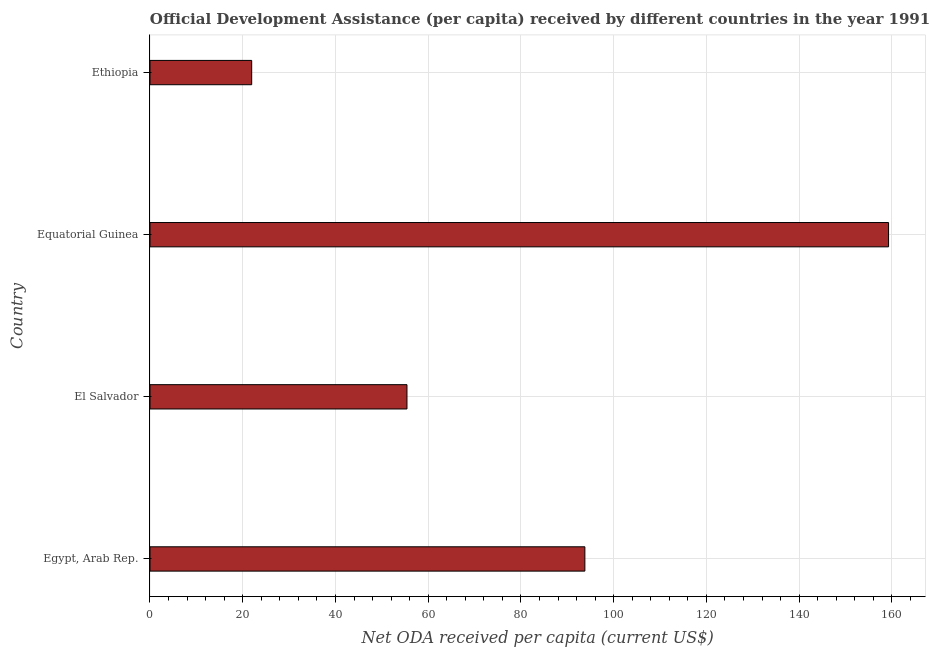Does the graph contain grids?
Your response must be concise. Yes. What is the title of the graph?
Offer a very short reply. Official Development Assistance (per capita) received by different countries in the year 1991. What is the label or title of the X-axis?
Your answer should be compact. Net ODA received per capita (current US$). What is the label or title of the Y-axis?
Offer a terse response. Country. What is the net oda received per capita in Equatorial Guinea?
Ensure brevity in your answer.  159.28. Across all countries, what is the maximum net oda received per capita?
Your answer should be very brief. 159.28. Across all countries, what is the minimum net oda received per capita?
Keep it short and to the point. 21.93. In which country was the net oda received per capita maximum?
Ensure brevity in your answer.  Equatorial Guinea. In which country was the net oda received per capita minimum?
Offer a terse response. Ethiopia. What is the sum of the net oda received per capita?
Ensure brevity in your answer.  330.42. What is the difference between the net oda received per capita in El Salvador and Ethiopia?
Offer a terse response. 33.49. What is the average net oda received per capita per country?
Give a very brief answer. 82.61. What is the median net oda received per capita?
Make the answer very short. 74.6. What is the ratio of the net oda received per capita in Egypt, Arab Rep. to that in Equatorial Guinea?
Your answer should be compact. 0.59. Is the net oda received per capita in El Salvador less than that in Equatorial Guinea?
Offer a very short reply. Yes. Is the difference between the net oda received per capita in El Salvador and Ethiopia greater than the difference between any two countries?
Ensure brevity in your answer.  No. What is the difference between the highest and the second highest net oda received per capita?
Offer a very short reply. 65.49. What is the difference between the highest and the lowest net oda received per capita?
Give a very brief answer. 137.35. Are all the bars in the graph horizontal?
Ensure brevity in your answer.  Yes. How many countries are there in the graph?
Your answer should be very brief. 4. Are the values on the major ticks of X-axis written in scientific E-notation?
Make the answer very short. No. What is the Net ODA received per capita (current US$) in Egypt, Arab Rep.?
Your answer should be very brief. 93.79. What is the Net ODA received per capita (current US$) of El Salvador?
Offer a very short reply. 55.42. What is the Net ODA received per capita (current US$) in Equatorial Guinea?
Keep it short and to the point. 159.28. What is the Net ODA received per capita (current US$) in Ethiopia?
Your response must be concise. 21.93. What is the difference between the Net ODA received per capita (current US$) in Egypt, Arab Rep. and El Salvador?
Make the answer very short. 38.37. What is the difference between the Net ODA received per capita (current US$) in Egypt, Arab Rep. and Equatorial Guinea?
Provide a short and direct response. -65.49. What is the difference between the Net ODA received per capita (current US$) in Egypt, Arab Rep. and Ethiopia?
Make the answer very short. 71.85. What is the difference between the Net ODA received per capita (current US$) in El Salvador and Equatorial Guinea?
Offer a very short reply. -103.86. What is the difference between the Net ODA received per capita (current US$) in El Salvador and Ethiopia?
Give a very brief answer. 33.49. What is the difference between the Net ODA received per capita (current US$) in Equatorial Guinea and Ethiopia?
Your answer should be very brief. 137.35. What is the ratio of the Net ODA received per capita (current US$) in Egypt, Arab Rep. to that in El Salvador?
Keep it short and to the point. 1.69. What is the ratio of the Net ODA received per capita (current US$) in Egypt, Arab Rep. to that in Equatorial Guinea?
Keep it short and to the point. 0.59. What is the ratio of the Net ODA received per capita (current US$) in Egypt, Arab Rep. to that in Ethiopia?
Provide a succinct answer. 4.28. What is the ratio of the Net ODA received per capita (current US$) in El Salvador to that in Equatorial Guinea?
Provide a short and direct response. 0.35. What is the ratio of the Net ODA received per capita (current US$) in El Salvador to that in Ethiopia?
Provide a succinct answer. 2.53. What is the ratio of the Net ODA received per capita (current US$) in Equatorial Guinea to that in Ethiopia?
Provide a succinct answer. 7.26. 